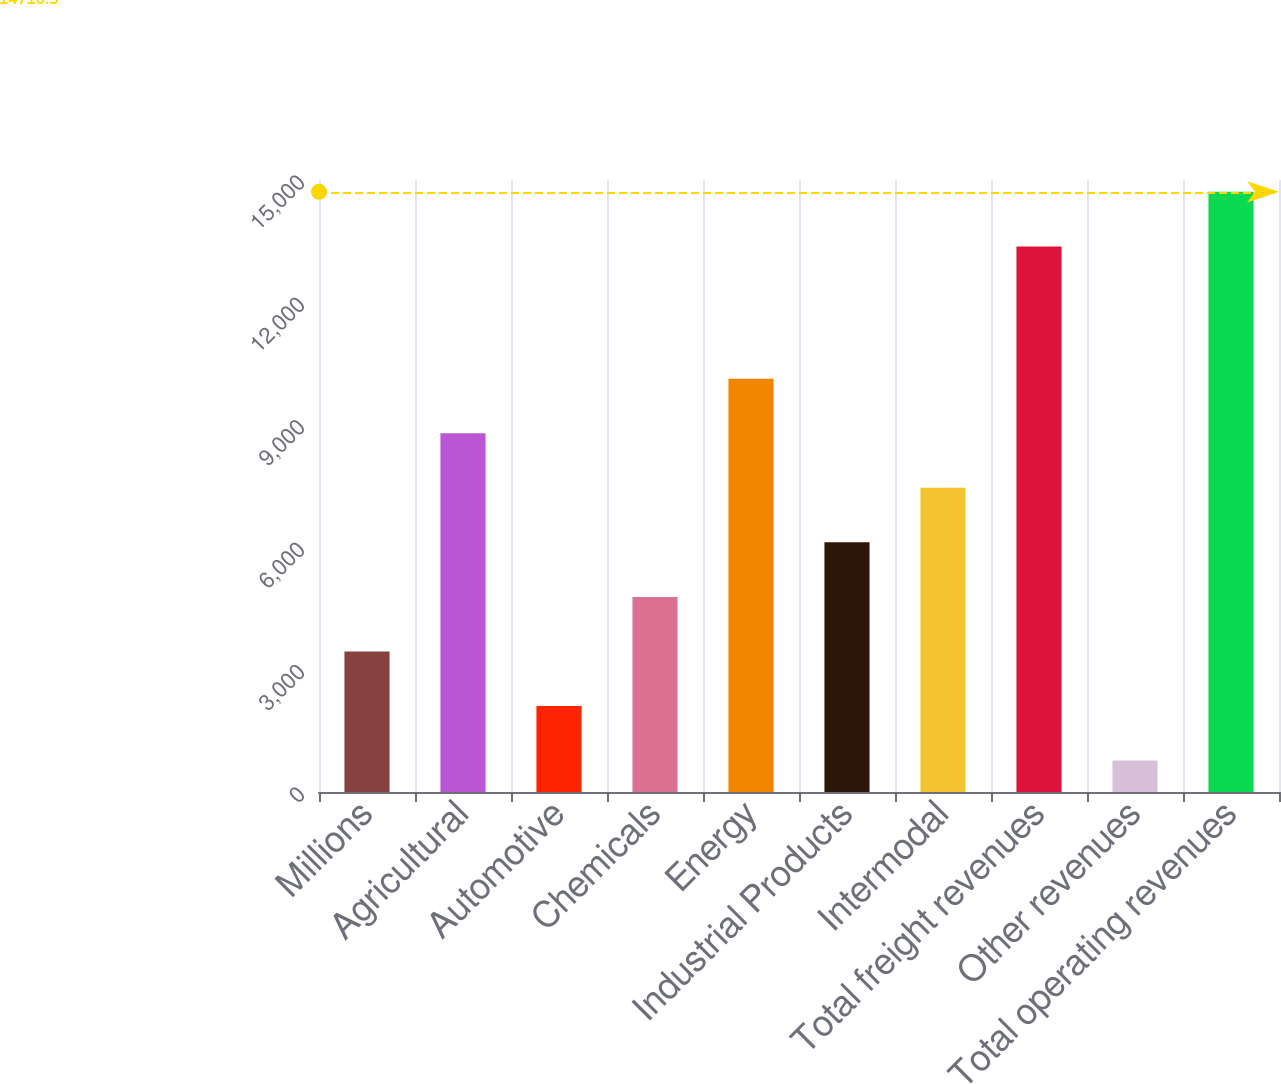Convert chart. <chart><loc_0><loc_0><loc_500><loc_500><bar_chart><fcel>Millions<fcel>Agricultural<fcel>Automotive<fcel>Chemicals<fcel>Energy<fcel>Industrial Products<fcel>Intermodal<fcel>Total freight revenues<fcel>Other revenues<fcel>Total operating revenues<nl><fcel>3444.6<fcel>8793.8<fcel>2107.3<fcel>4781.9<fcel>10131.1<fcel>6119.2<fcel>7456.5<fcel>13373<fcel>770<fcel>14710.3<nl></chart> 